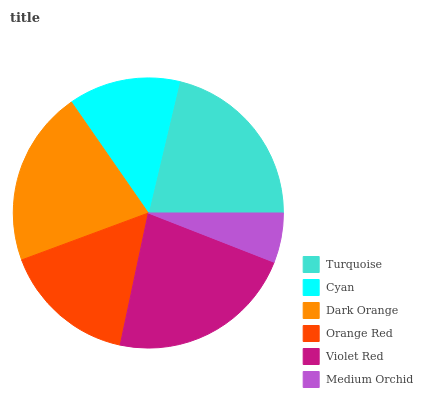Is Medium Orchid the minimum?
Answer yes or no. Yes. Is Violet Red the maximum?
Answer yes or no. Yes. Is Cyan the minimum?
Answer yes or no. No. Is Cyan the maximum?
Answer yes or no. No. Is Turquoise greater than Cyan?
Answer yes or no. Yes. Is Cyan less than Turquoise?
Answer yes or no. Yes. Is Cyan greater than Turquoise?
Answer yes or no. No. Is Turquoise less than Cyan?
Answer yes or no. No. Is Dark Orange the high median?
Answer yes or no. Yes. Is Orange Red the low median?
Answer yes or no. Yes. Is Medium Orchid the high median?
Answer yes or no. No. Is Turquoise the low median?
Answer yes or no. No. 